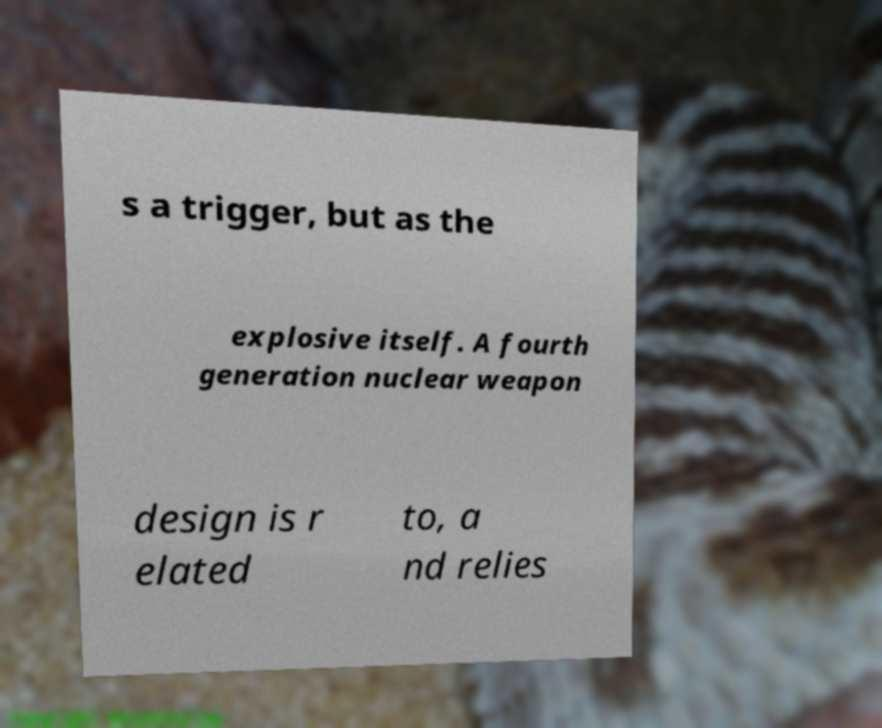Could you assist in decoding the text presented in this image and type it out clearly? s a trigger, but as the explosive itself. A fourth generation nuclear weapon design is r elated to, a nd relies 